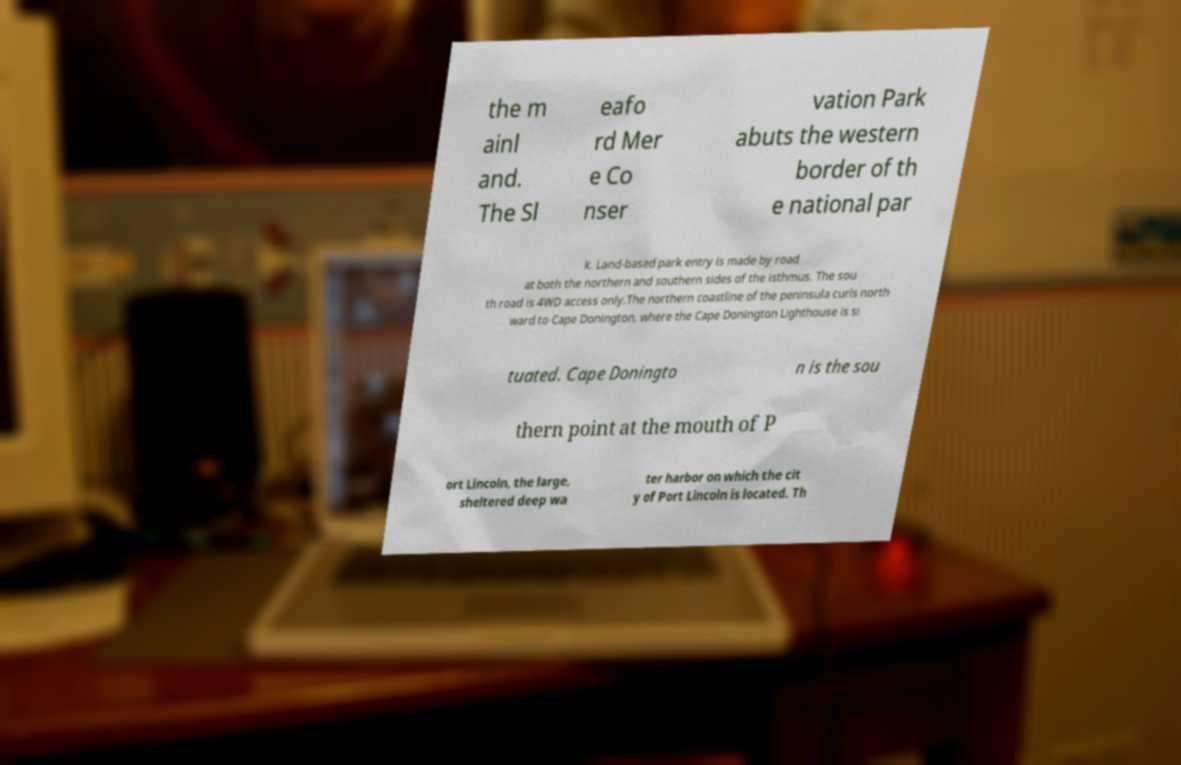Could you extract and type out the text from this image? the m ainl and. The Sl eafo rd Mer e Co nser vation Park abuts the western border of th e national par k. Land-based park entry is made by road at both the northern and southern sides of the isthmus. The sou th road is 4WD access only.The northern coastline of the peninsula curls north ward to Cape Donington, where the Cape Donington Lighthouse is si tuated. Cape Doningto n is the sou thern point at the mouth of P ort Lincoln, the large, sheltered deep wa ter harbor on which the cit y of Port Lincoln is located. Th 